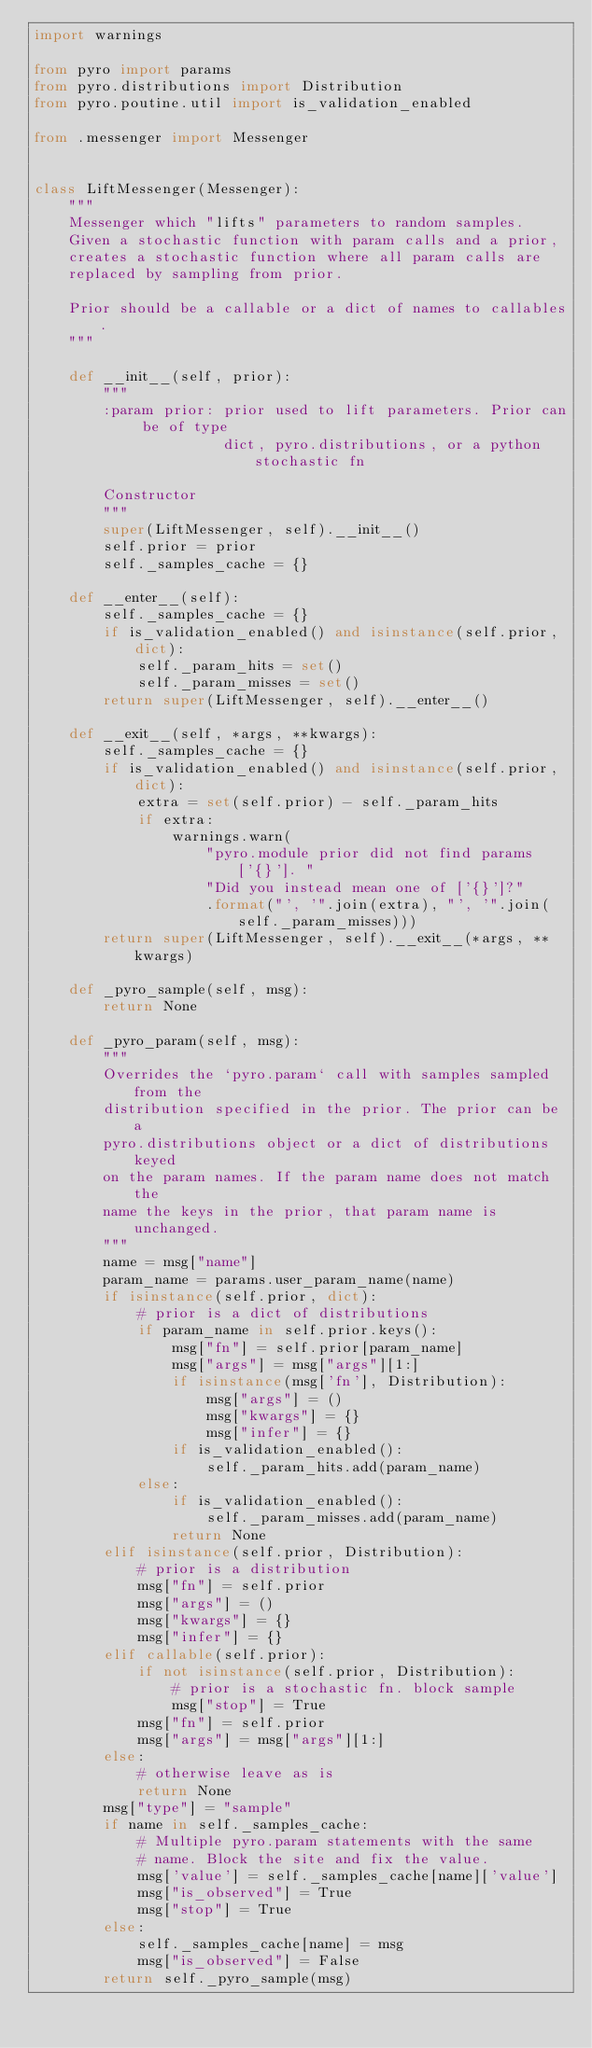<code> <loc_0><loc_0><loc_500><loc_500><_Python_>import warnings

from pyro import params
from pyro.distributions import Distribution
from pyro.poutine.util import is_validation_enabled

from .messenger import Messenger


class LiftMessenger(Messenger):
    """
    Messenger which "lifts" parameters to random samples.
    Given a stochastic function with param calls and a prior,
    creates a stochastic function where all param calls are
    replaced by sampling from prior.

    Prior should be a callable or a dict of names to callables.
    """

    def __init__(self, prior):
        """
        :param prior: prior used to lift parameters. Prior can be of type
                      dict, pyro.distributions, or a python stochastic fn

        Constructor
        """
        super(LiftMessenger, self).__init__()
        self.prior = prior
        self._samples_cache = {}

    def __enter__(self):
        self._samples_cache = {}
        if is_validation_enabled() and isinstance(self.prior, dict):
            self._param_hits = set()
            self._param_misses = set()
        return super(LiftMessenger, self).__enter__()

    def __exit__(self, *args, **kwargs):
        self._samples_cache = {}
        if is_validation_enabled() and isinstance(self.prior, dict):
            extra = set(self.prior) - self._param_hits
            if extra:
                warnings.warn(
                    "pyro.module prior did not find params ['{}']. "
                    "Did you instead mean one of ['{}']?"
                    .format("', '".join(extra), "', '".join(self._param_misses)))
        return super(LiftMessenger, self).__exit__(*args, **kwargs)

    def _pyro_sample(self, msg):
        return None

    def _pyro_param(self, msg):
        """
        Overrides the `pyro.param` call with samples sampled from the
        distribution specified in the prior. The prior can be a
        pyro.distributions object or a dict of distributions keyed
        on the param names. If the param name does not match the
        name the keys in the prior, that param name is unchanged.
        """
        name = msg["name"]
        param_name = params.user_param_name(name)
        if isinstance(self.prior, dict):
            # prior is a dict of distributions
            if param_name in self.prior.keys():
                msg["fn"] = self.prior[param_name]
                msg["args"] = msg["args"][1:]
                if isinstance(msg['fn'], Distribution):
                    msg["args"] = ()
                    msg["kwargs"] = {}
                    msg["infer"] = {}
                if is_validation_enabled():
                    self._param_hits.add(param_name)
            else:
                if is_validation_enabled():
                    self._param_misses.add(param_name)
                return None
        elif isinstance(self.prior, Distribution):
            # prior is a distribution
            msg["fn"] = self.prior
            msg["args"] = ()
            msg["kwargs"] = {}
            msg["infer"] = {}
        elif callable(self.prior):
            if not isinstance(self.prior, Distribution):
                # prior is a stochastic fn. block sample
                msg["stop"] = True
            msg["fn"] = self.prior
            msg["args"] = msg["args"][1:]
        else:
            # otherwise leave as is
            return None
        msg["type"] = "sample"
        if name in self._samples_cache:
            # Multiple pyro.param statements with the same
            # name. Block the site and fix the value.
            msg['value'] = self._samples_cache[name]['value']
            msg["is_observed"] = True
            msg["stop"] = True
        else:
            self._samples_cache[name] = msg
            msg["is_observed"] = False
        return self._pyro_sample(msg)
</code> 